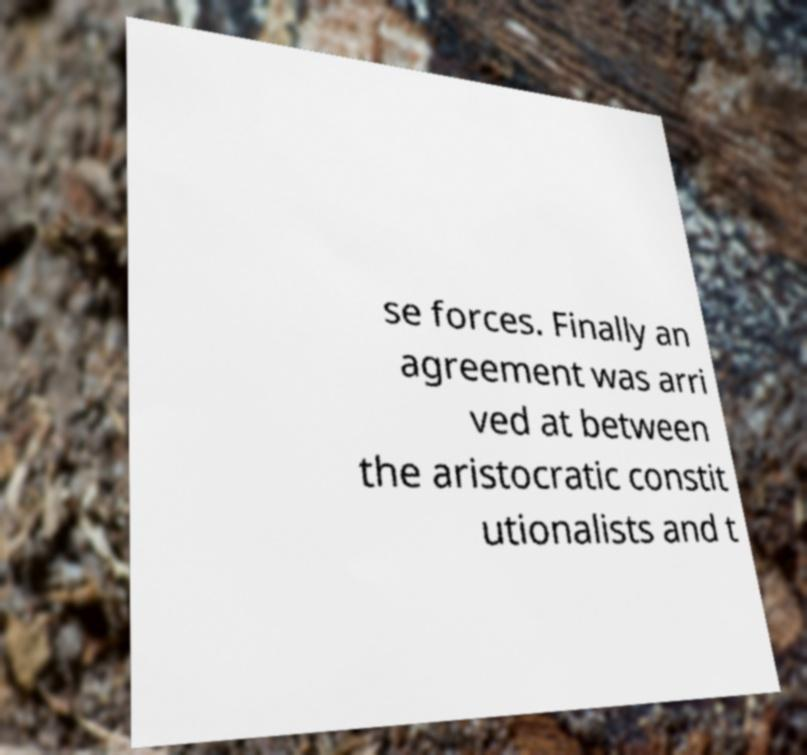Please read and relay the text visible in this image. What does it say? se forces. Finally an agreement was arri ved at between the aristocratic constit utionalists and t 